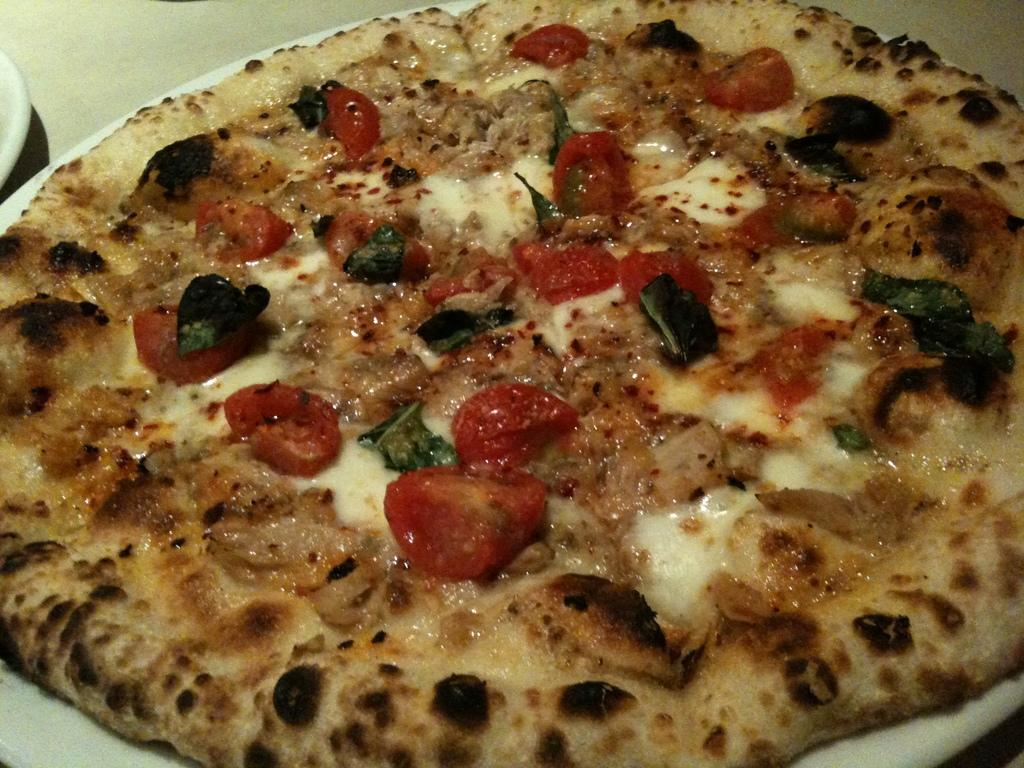What is on the plate in the image? There is a plate with food in the image. Can you describe the white object on the plate or surface of the image? There is a white object on the surface of the plate or image. How many donkeys are present in the image? There are no donkeys present in the image. What is the size of the sheep in the image? There are no sheep present in the image. 